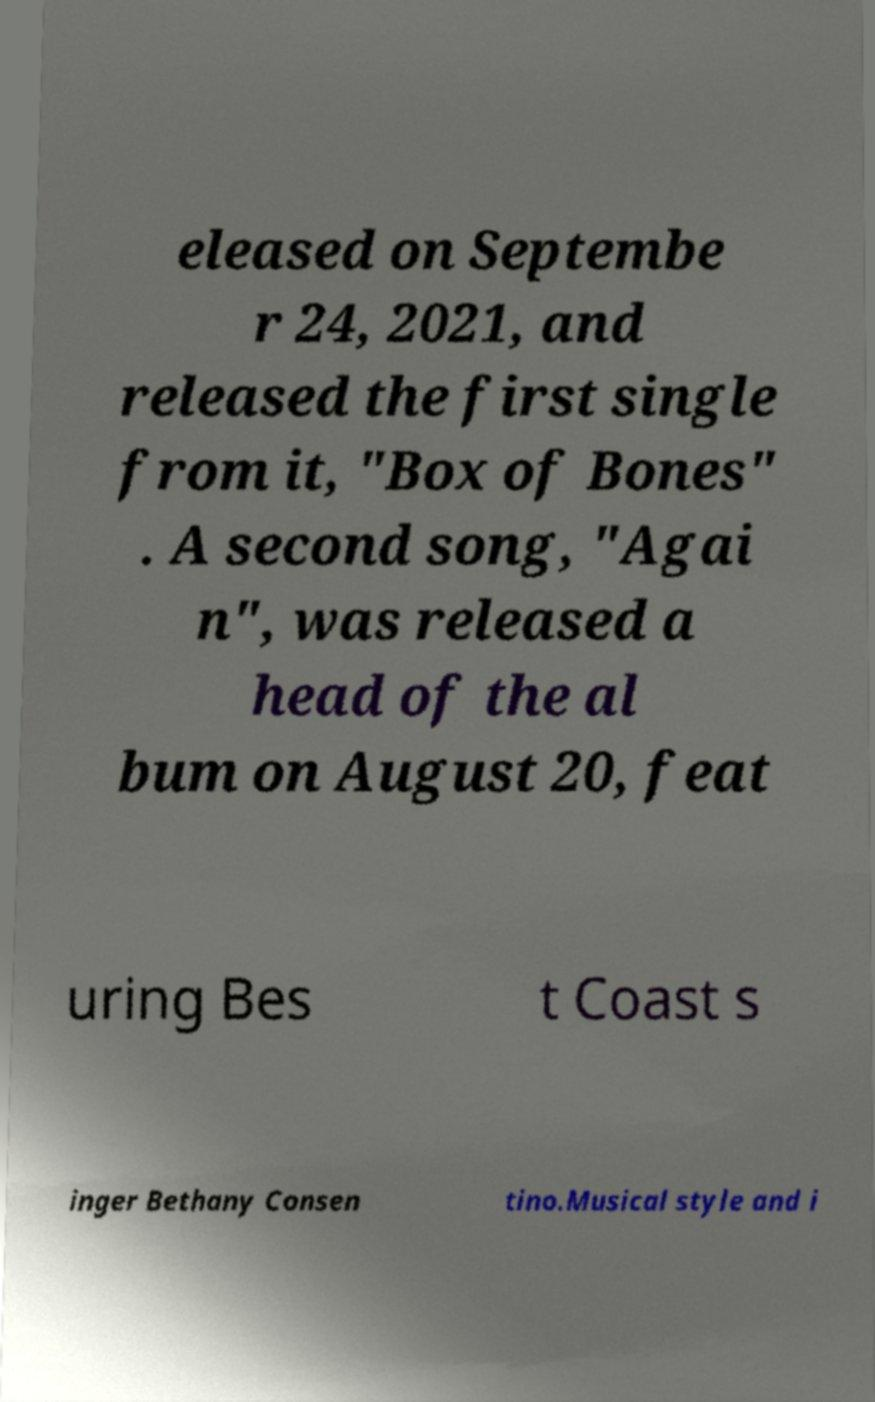Please identify and transcribe the text found in this image. eleased on Septembe r 24, 2021, and released the first single from it, "Box of Bones" . A second song, "Agai n", was released a head of the al bum on August 20, feat uring Bes t Coast s inger Bethany Consen tino.Musical style and i 